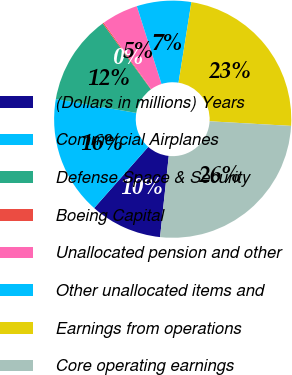Convert chart. <chart><loc_0><loc_0><loc_500><loc_500><pie_chart><fcel>(Dollars in millions) Years<fcel>Commercial Airplanes<fcel>Defense Space & Security<fcel>Boeing Capital<fcel>Unallocated pension and other<fcel>Other unallocated items and<fcel>Earnings from operations<fcel>Core operating earnings<nl><fcel>9.82%<fcel>16.2%<fcel>12.24%<fcel>0.16%<fcel>4.99%<fcel>7.41%<fcel>23.38%<fcel>25.8%<nl></chart> 